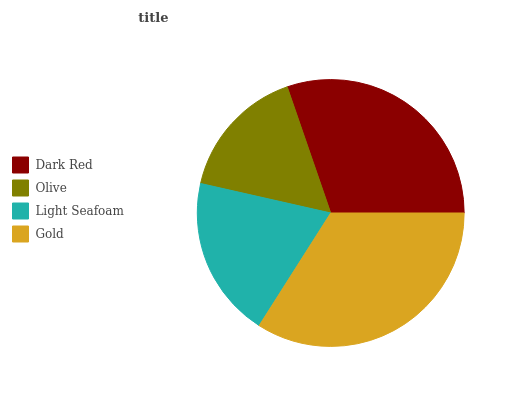Is Olive the minimum?
Answer yes or no. Yes. Is Gold the maximum?
Answer yes or no. Yes. Is Light Seafoam the minimum?
Answer yes or no. No. Is Light Seafoam the maximum?
Answer yes or no. No. Is Light Seafoam greater than Olive?
Answer yes or no. Yes. Is Olive less than Light Seafoam?
Answer yes or no. Yes. Is Olive greater than Light Seafoam?
Answer yes or no. No. Is Light Seafoam less than Olive?
Answer yes or no. No. Is Dark Red the high median?
Answer yes or no. Yes. Is Light Seafoam the low median?
Answer yes or no. Yes. Is Gold the high median?
Answer yes or no. No. Is Gold the low median?
Answer yes or no. No. 